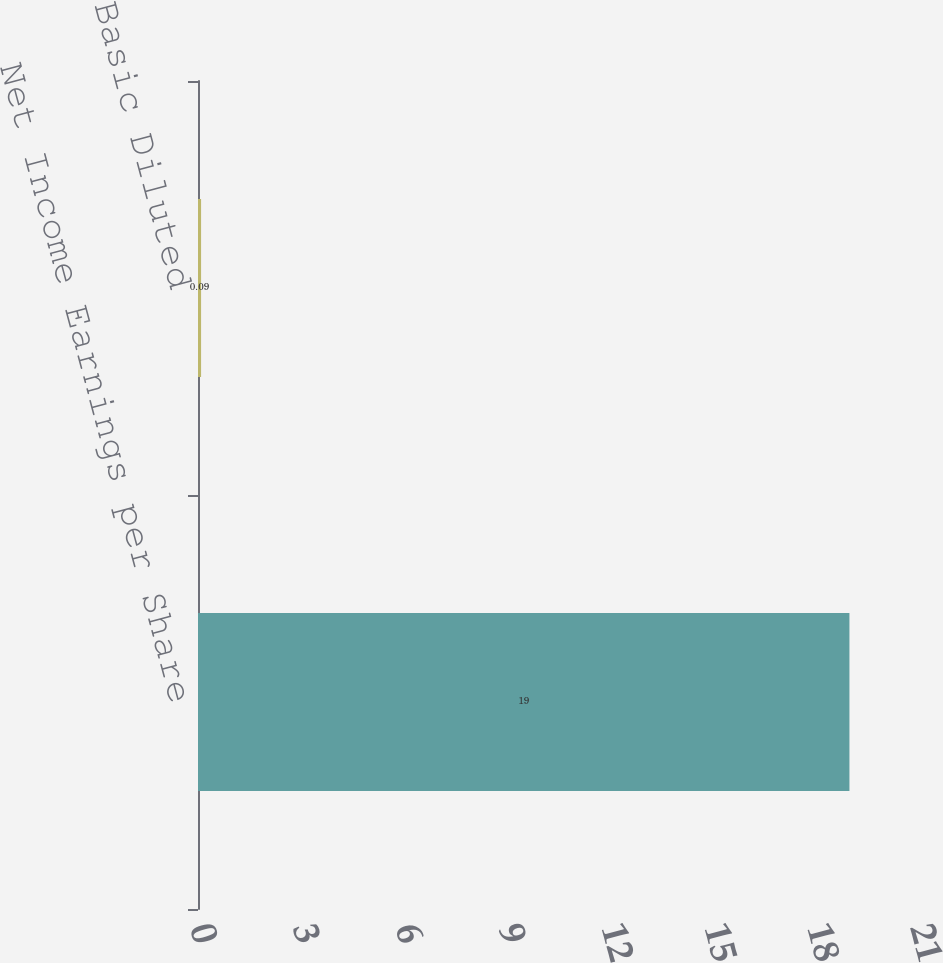Convert chart to OTSL. <chart><loc_0><loc_0><loc_500><loc_500><bar_chart><fcel>Net Income Earnings per Share<fcel>Basic Diluted<nl><fcel>19<fcel>0.09<nl></chart> 